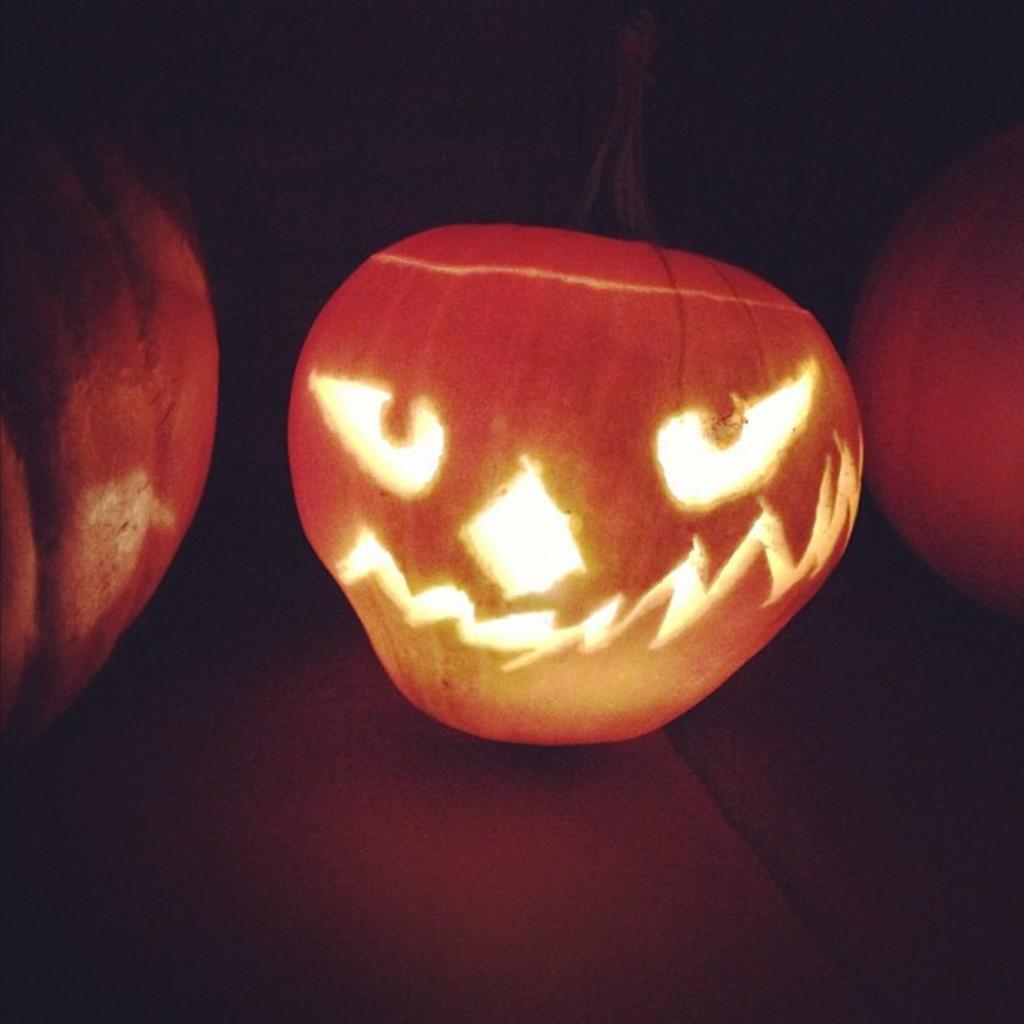Could you give a brief overview of what you see in this image? In this image we can see a group of pumpkins placed on the floor. One pumpkin is carved in shape of a face. 